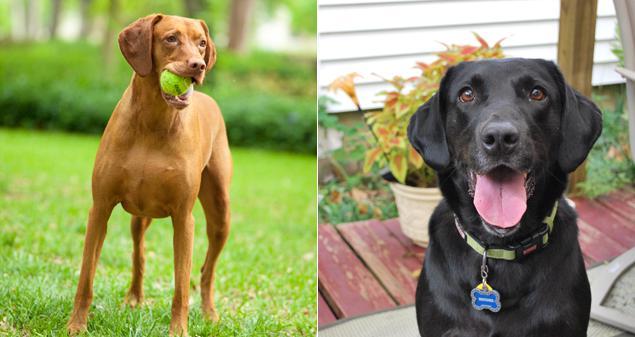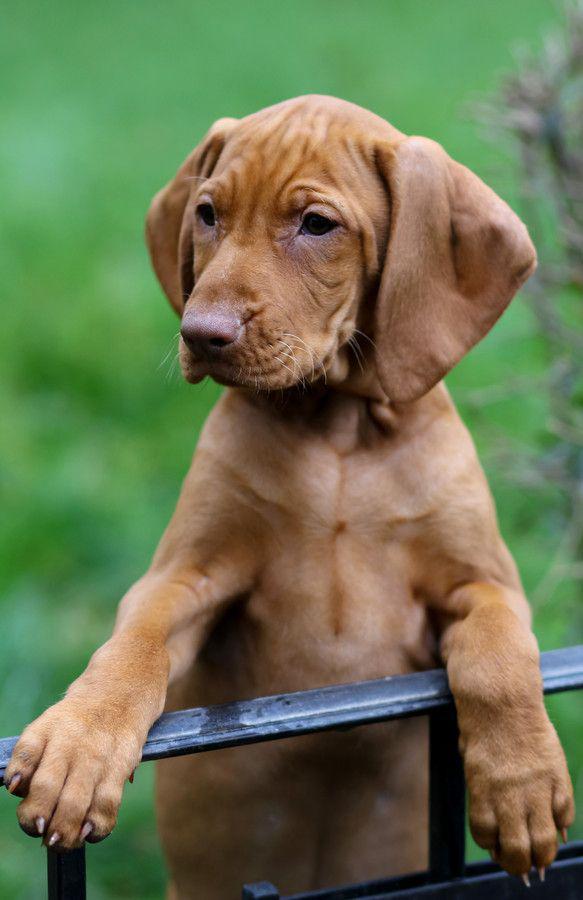The first image is the image on the left, the second image is the image on the right. Analyze the images presented: Is the assertion "The left image shows a row of three dogs with upright heads, and the right image shows one upright dog wearing a collar." valid? Answer yes or no. No. The first image is the image on the left, the second image is the image on the right. For the images shown, is this caption "In the image on the left there are 3 dogs." true? Answer yes or no. No. 